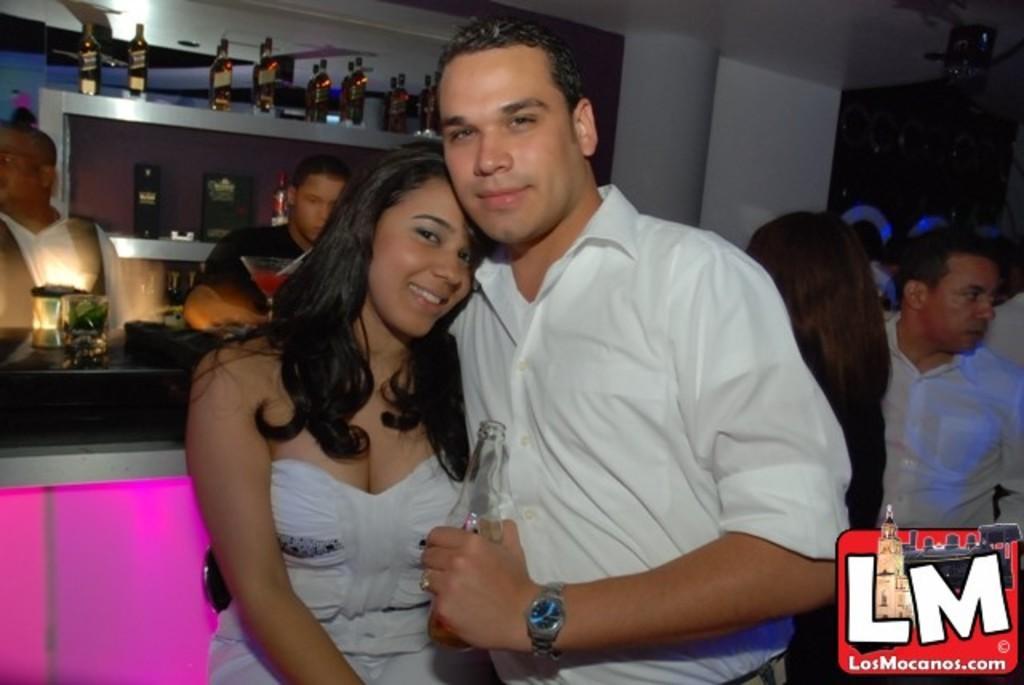Please provide a concise description of this image. In the foreground of this image, there is a couple in white dress standing and hugging and having smile on their faces. In the background, there are persons standing, a light and a glass on the desk, bottles in the shelf and the wall. 